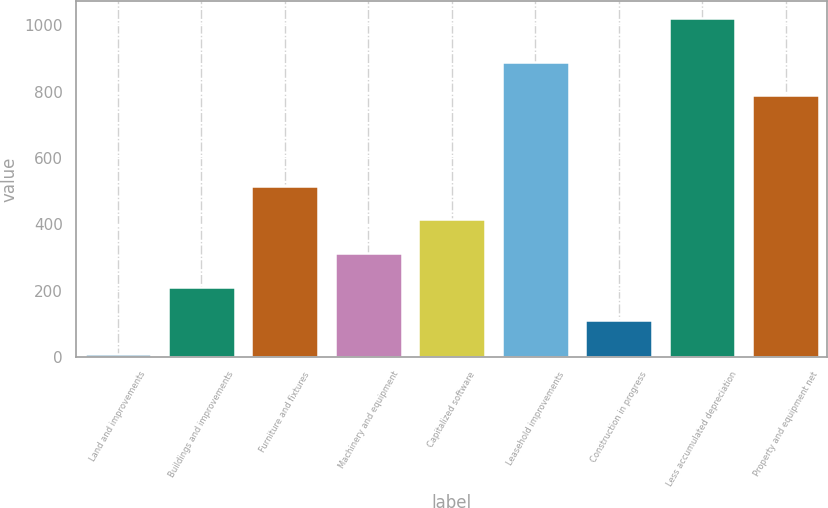Convert chart. <chart><loc_0><loc_0><loc_500><loc_500><bar_chart><fcel>Land and improvements<fcel>Buildings and improvements<fcel>Furniture and fixtures<fcel>Machinery and equipment<fcel>Capitalized software<fcel>Leasehold improvements<fcel>Construction in progress<fcel>Less accumulated depreciation<fcel>Property and equipment net<nl><fcel>9.9<fcel>212.22<fcel>515.7<fcel>313.38<fcel>414.54<fcel>889.96<fcel>111.06<fcel>1021.5<fcel>788.8<nl></chart> 